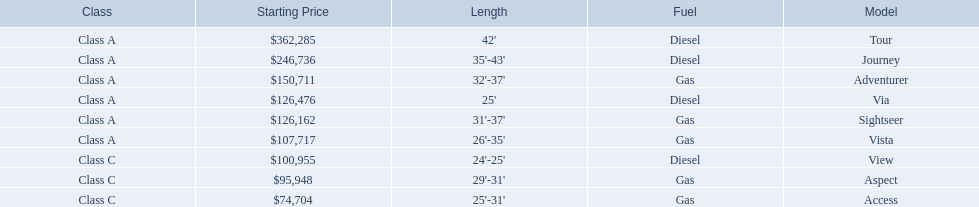Write the full table. {'header': ['Class', 'Starting Price', 'Length', 'Fuel', 'Model'], 'rows': [['Class A', '$362,285', "42'", 'Diesel', 'Tour'], ['Class A', '$246,736', "35'-43'", 'Diesel', 'Journey'], ['Class A', '$150,711', "32'-37'", 'Gas', 'Adventurer'], ['Class A', '$126,476', "25'", 'Diesel', 'Via'], ['Class A', '$126,162', "31'-37'", 'Gas', 'Sightseer'], ['Class A', '$107,717', "26'-35'", 'Gas', 'Vista'], ['Class C', '$100,955', "24'-25'", 'Diesel', 'View'], ['Class C', '$95,948', "29'-31'", 'Gas', 'Aspect'], ['Class C', '$74,704', "25'-31'", 'Gas', 'Access']]} What are all the class a models of the winnebago industries? Tour, Journey, Adventurer, Via, Sightseer, Vista. Of those class a models, which has the highest starting price? Tour. 